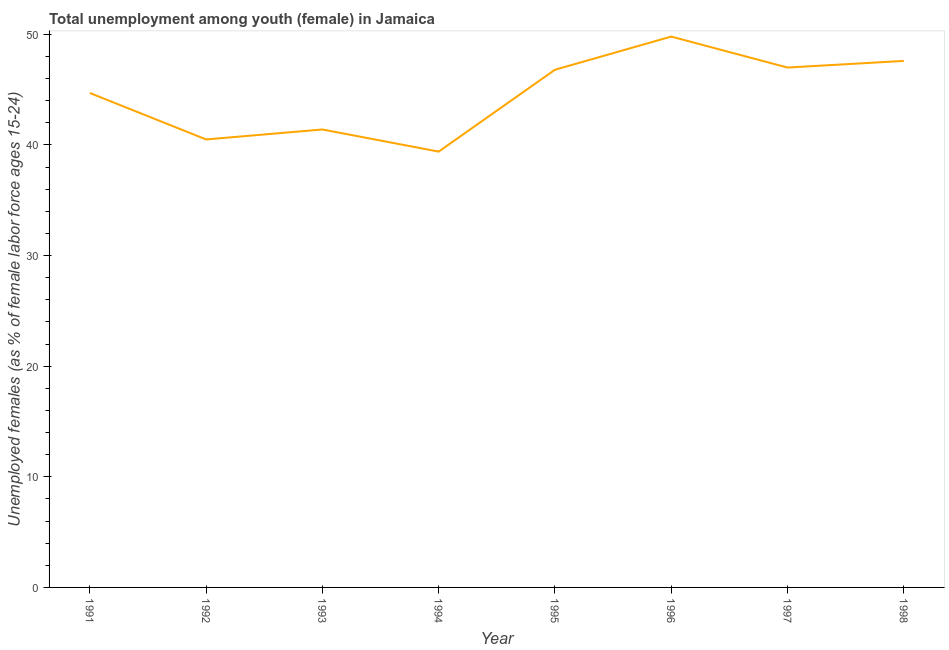What is the unemployed female youth population in 1992?
Offer a very short reply. 40.5. Across all years, what is the maximum unemployed female youth population?
Keep it short and to the point. 49.8. Across all years, what is the minimum unemployed female youth population?
Provide a short and direct response. 39.4. In which year was the unemployed female youth population minimum?
Provide a succinct answer. 1994. What is the sum of the unemployed female youth population?
Keep it short and to the point. 357.2. What is the difference between the unemployed female youth population in 1993 and 1995?
Your answer should be compact. -5.4. What is the average unemployed female youth population per year?
Your answer should be compact. 44.65. What is the median unemployed female youth population?
Provide a short and direct response. 45.75. In how many years, is the unemployed female youth population greater than 22 %?
Your response must be concise. 8. Do a majority of the years between 1995 and 1991 (inclusive) have unemployed female youth population greater than 44 %?
Keep it short and to the point. Yes. What is the ratio of the unemployed female youth population in 1992 to that in 1996?
Give a very brief answer. 0.81. Is the unemployed female youth population in 1991 less than that in 1996?
Your answer should be very brief. Yes. What is the difference between the highest and the second highest unemployed female youth population?
Your answer should be compact. 2.2. What is the difference between the highest and the lowest unemployed female youth population?
Provide a succinct answer. 10.4. Does the unemployed female youth population monotonically increase over the years?
Keep it short and to the point. No. How many lines are there?
Your answer should be very brief. 1. How many years are there in the graph?
Provide a short and direct response. 8. What is the title of the graph?
Give a very brief answer. Total unemployment among youth (female) in Jamaica. What is the label or title of the X-axis?
Offer a very short reply. Year. What is the label or title of the Y-axis?
Give a very brief answer. Unemployed females (as % of female labor force ages 15-24). What is the Unemployed females (as % of female labor force ages 15-24) of 1991?
Keep it short and to the point. 44.7. What is the Unemployed females (as % of female labor force ages 15-24) in 1992?
Your response must be concise. 40.5. What is the Unemployed females (as % of female labor force ages 15-24) in 1993?
Your answer should be compact. 41.4. What is the Unemployed females (as % of female labor force ages 15-24) of 1994?
Give a very brief answer. 39.4. What is the Unemployed females (as % of female labor force ages 15-24) of 1995?
Offer a very short reply. 46.8. What is the Unemployed females (as % of female labor force ages 15-24) of 1996?
Provide a short and direct response. 49.8. What is the Unemployed females (as % of female labor force ages 15-24) in 1998?
Your answer should be very brief. 47.6. What is the difference between the Unemployed females (as % of female labor force ages 15-24) in 1991 and 1992?
Provide a short and direct response. 4.2. What is the difference between the Unemployed females (as % of female labor force ages 15-24) in 1991 and 1993?
Your response must be concise. 3.3. What is the difference between the Unemployed females (as % of female labor force ages 15-24) in 1991 and 1997?
Provide a succinct answer. -2.3. What is the difference between the Unemployed females (as % of female labor force ages 15-24) in 1991 and 1998?
Offer a very short reply. -2.9. What is the difference between the Unemployed females (as % of female labor force ages 15-24) in 1992 and 1998?
Your answer should be compact. -7.1. What is the difference between the Unemployed females (as % of female labor force ages 15-24) in 1993 and 1994?
Your answer should be compact. 2. What is the difference between the Unemployed females (as % of female labor force ages 15-24) in 1993 and 1995?
Offer a very short reply. -5.4. What is the difference between the Unemployed females (as % of female labor force ages 15-24) in 1993 and 1996?
Provide a short and direct response. -8.4. What is the difference between the Unemployed females (as % of female labor force ages 15-24) in 1993 and 1997?
Provide a succinct answer. -5.6. What is the difference between the Unemployed females (as % of female labor force ages 15-24) in 1993 and 1998?
Your response must be concise. -6.2. What is the difference between the Unemployed females (as % of female labor force ages 15-24) in 1994 and 1995?
Offer a very short reply. -7.4. What is the difference between the Unemployed females (as % of female labor force ages 15-24) in 1994 and 1997?
Provide a succinct answer. -7.6. What is the difference between the Unemployed females (as % of female labor force ages 15-24) in 1995 and 1996?
Provide a short and direct response. -3. What is the difference between the Unemployed females (as % of female labor force ages 15-24) in 1995 and 1997?
Keep it short and to the point. -0.2. What is the difference between the Unemployed females (as % of female labor force ages 15-24) in 1995 and 1998?
Give a very brief answer. -0.8. What is the ratio of the Unemployed females (as % of female labor force ages 15-24) in 1991 to that in 1992?
Your answer should be compact. 1.1. What is the ratio of the Unemployed females (as % of female labor force ages 15-24) in 1991 to that in 1994?
Your answer should be very brief. 1.14. What is the ratio of the Unemployed females (as % of female labor force ages 15-24) in 1991 to that in 1995?
Make the answer very short. 0.95. What is the ratio of the Unemployed females (as % of female labor force ages 15-24) in 1991 to that in 1996?
Give a very brief answer. 0.9. What is the ratio of the Unemployed females (as % of female labor force ages 15-24) in 1991 to that in 1997?
Your answer should be compact. 0.95. What is the ratio of the Unemployed females (as % of female labor force ages 15-24) in 1991 to that in 1998?
Provide a succinct answer. 0.94. What is the ratio of the Unemployed females (as % of female labor force ages 15-24) in 1992 to that in 1994?
Your answer should be compact. 1.03. What is the ratio of the Unemployed females (as % of female labor force ages 15-24) in 1992 to that in 1995?
Ensure brevity in your answer.  0.86. What is the ratio of the Unemployed females (as % of female labor force ages 15-24) in 1992 to that in 1996?
Your answer should be very brief. 0.81. What is the ratio of the Unemployed females (as % of female labor force ages 15-24) in 1992 to that in 1997?
Your answer should be very brief. 0.86. What is the ratio of the Unemployed females (as % of female labor force ages 15-24) in 1992 to that in 1998?
Provide a succinct answer. 0.85. What is the ratio of the Unemployed females (as % of female labor force ages 15-24) in 1993 to that in 1994?
Your answer should be compact. 1.05. What is the ratio of the Unemployed females (as % of female labor force ages 15-24) in 1993 to that in 1995?
Provide a succinct answer. 0.89. What is the ratio of the Unemployed females (as % of female labor force ages 15-24) in 1993 to that in 1996?
Provide a short and direct response. 0.83. What is the ratio of the Unemployed females (as % of female labor force ages 15-24) in 1993 to that in 1997?
Offer a very short reply. 0.88. What is the ratio of the Unemployed females (as % of female labor force ages 15-24) in 1993 to that in 1998?
Provide a short and direct response. 0.87. What is the ratio of the Unemployed females (as % of female labor force ages 15-24) in 1994 to that in 1995?
Your response must be concise. 0.84. What is the ratio of the Unemployed females (as % of female labor force ages 15-24) in 1994 to that in 1996?
Offer a terse response. 0.79. What is the ratio of the Unemployed females (as % of female labor force ages 15-24) in 1994 to that in 1997?
Your answer should be very brief. 0.84. What is the ratio of the Unemployed females (as % of female labor force ages 15-24) in 1994 to that in 1998?
Ensure brevity in your answer.  0.83. What is the ratio of the Unemployed females (as % of female labor force ages 15-24) in 1995 to that in 1997?
Offer a very short reply. 1. What is the ratio of the Unemployed females (as % of female labor force ages 15-24) in 1996 to that in 1997?
Your response must be concise. 1.06. What is the ratio of the Unemployed females (as % of female labor force ages 15-24) in 1996 to that in 1998?
Give a very brief answer. 1.05. What is the ratio of the Unemployed females (as % of female labor force ages 15-24) in 1997 to that in 1998?
Give a very brief answer. 0.99. 